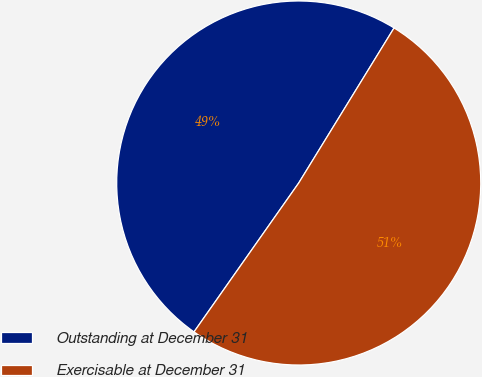Convert chart. <chart><loc_0><loc_0><loc_500><loc_500><pie_chart><fcel>Outstanding at December 31<fcel>Exercisable at December 31<nl><fcel>49.02%<fcel>50.98%<nl></chart> 